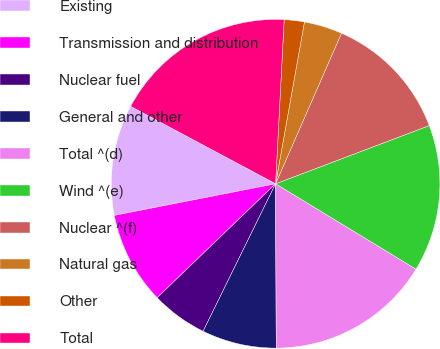Convert chart. <chart><loc_0><loc_0><loc_500><loc_500><pie_chart><fcel>Existing<fcel>Transmission and distribution<fcel>Nuclear fuel<fcel>General and other<fcel>Total ^(d)<fcel>Wind ^(e)<fcel>Nuclear ^(f)<fcel>Natural gas<fcel>Other<fcel>Total<nl><fcel>10.89%<fcel>9.11%<fcel>5.54%<fcel>7.33%<fcel>16.24%<fcel>14.46%<fcel>12.67%<fcel>3.76%<fcel>1.98%<fcel>18.02%<nl></chart> 